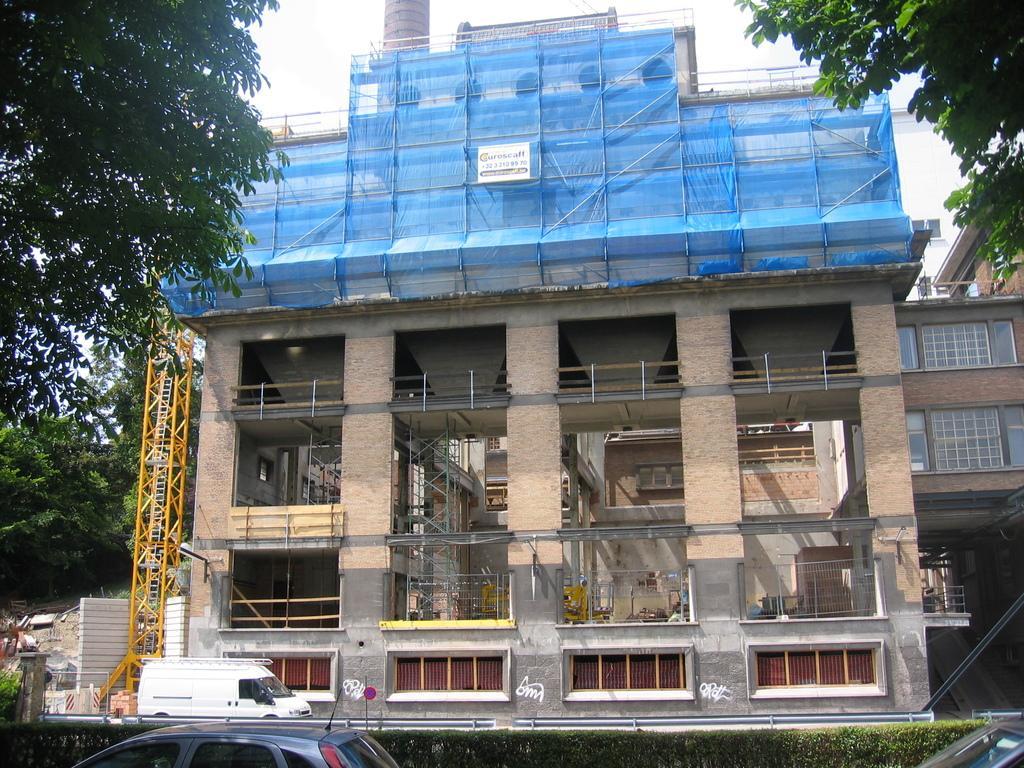Can you describe this image briefly? This picture is clicked outside. In the foreground we can see a tree, vehicles, shrubs, metal rods and some other items. In the center we can see the buildings, windows and walls of the buildings and we can see the blue color curtains. In the background there is a sky and the trees. 